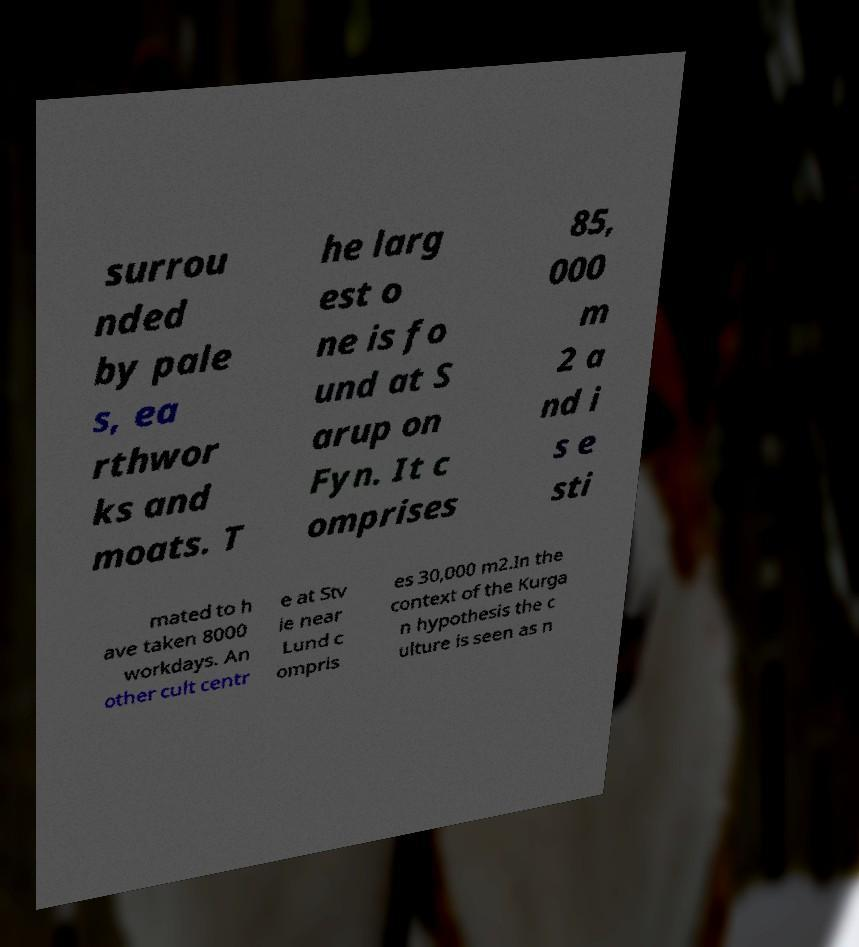Please read and relay the text visible in this image. What does it say? surrou nded by pale s, ea rthwor ks and moats. T he larg est o ne is fo und at S arup on Fyn. It c omprises 85, 000 m 2 a nd i s e sti mated to h ave taken 8000 workdays. An other cult centr e at Stv ie near Lund c ompris es 30,000 m2.In the context of the Kurga n hypothesis the c ulture is seen as n 